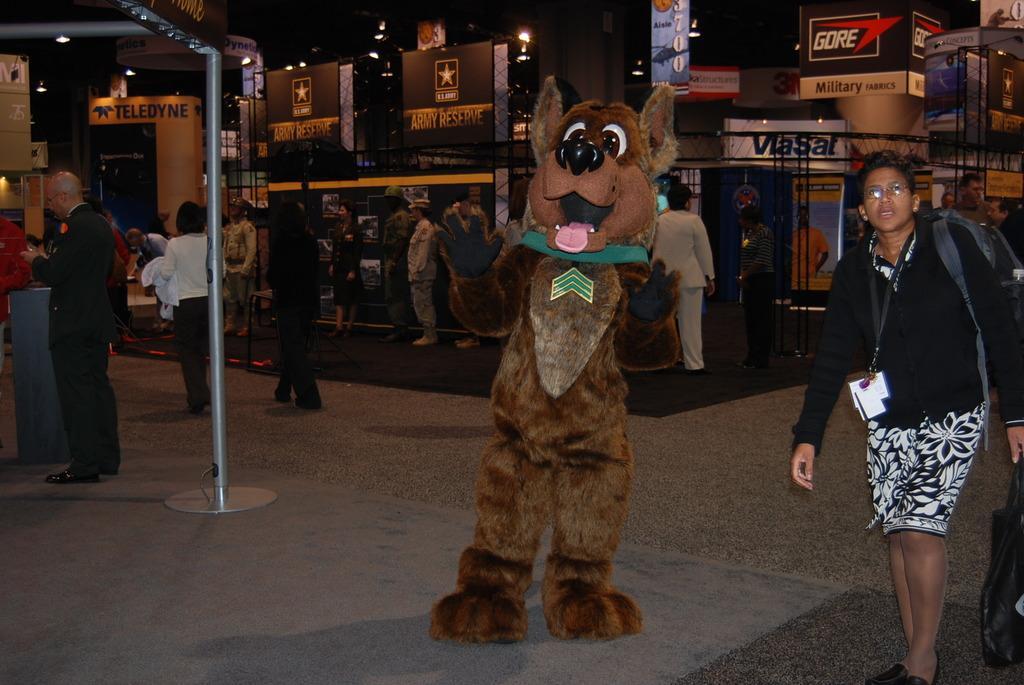Can you describe this image briefly? In this picture I can observe a person wearing a costume of an animal. There are some people walking in the background. I can observe a pole on the left side. 